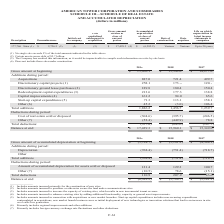According to American Tower Corporation's financial document, What did the calculation of Other primarily include? foreign currency exchange rate fluctuations and other deductions.. The document states: "(7) Primarily includes foreign currency exchange rate fluctuations and other deductions...." Also, What was the depreciation cost in 2019? According to the financial document, (768.4) (in millions). The relevant text states: "Depreciation (768.4) (751.4) (718.7)..." Also, What was the total additions in 2017? According to the financial document, (718.7) (in millions). The relevant text states: "Depreciation (768.4) (751.4) (718.7)..." Also, can you calculate: What was the change in depreciation between 2018 and 2019? Based on the calculation: -768.4-(-751.4), the result is -17 (in millions). This is based on the information: "Depreciation (768.4) (751.4) (718.7) Depreciation (768.4) (751.4) (718.7)..." The key data points involved are: 751.4, 768.4. Also, can you calculate: What was the change in Gross amount of accumulated depreciation at beginning between 2017 and 2018? Based on the calculation: -$5,181.2-(-$4,548.1), the result is -633.1 (in millions). This is based on the information: "reciation at beginning $ (5,724.7) $ (5,181.2) $ (4,548.1) umulated depreciation at beginning $ (5,724.7) $ (5,181.2) $ (4,548.1)..." The key data points involved are: 4,548.1, 5,181.2. Also, can you calculate: What was the percentage change in total deductions between 2018 and 2019? To answer this question, I need to perform calculations using the financial data. The calculation is: (110.9-207.9)/207.9, which equals -46.66 (percentage). This is based on the information: "Total deductions 110.9 207.9 85.6 Total deductions 110.9 207.9 85.6..." The key data points involved are: 110.9, 207.9. 